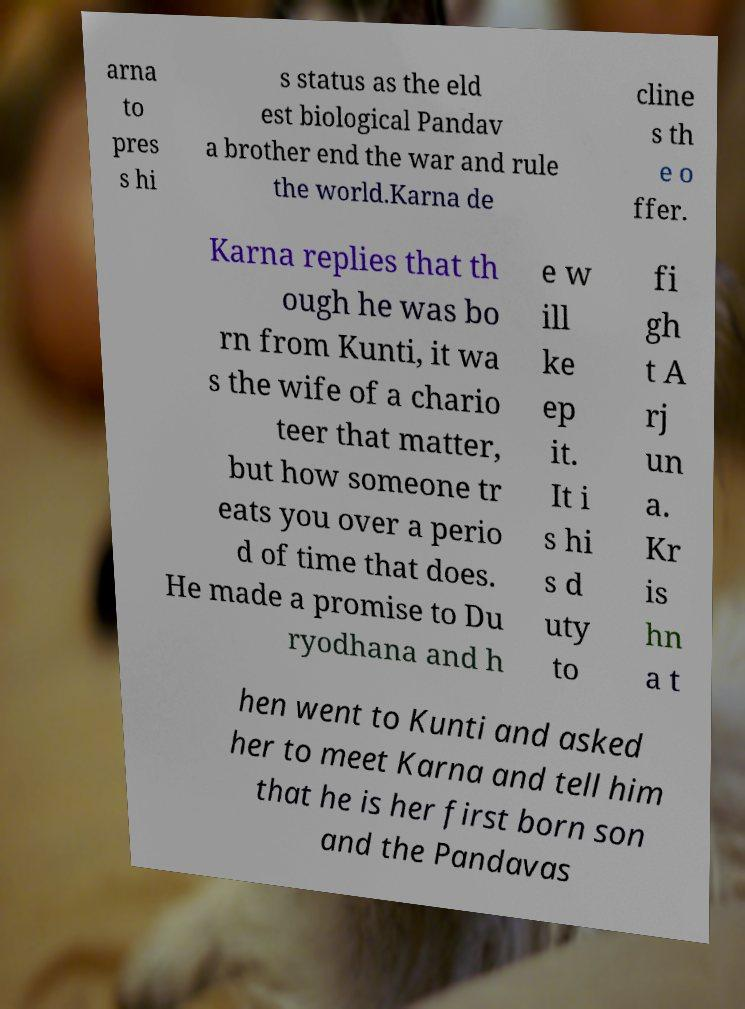For documentation purposes, I need the text within this image transcribed. Could you provide that? arna to pres s hi s status as the eld est biological Pandav a brother end the war and rule the world.Karna de cline s th e o ffer. Karna replies that th ough he was bo rn from Kunti, it wa s the wife of a chario teer that matter, but how someone tr eats you over a perio d of time that does. He made a promise to Du ryodhana and h e w ill ke ep it. It i s hi s d uty to fi gh t A rj un a. Kr is hn a t hen went to Kunti and asked her to meet Karna and tell him that he is her first born son and the Pandavas 